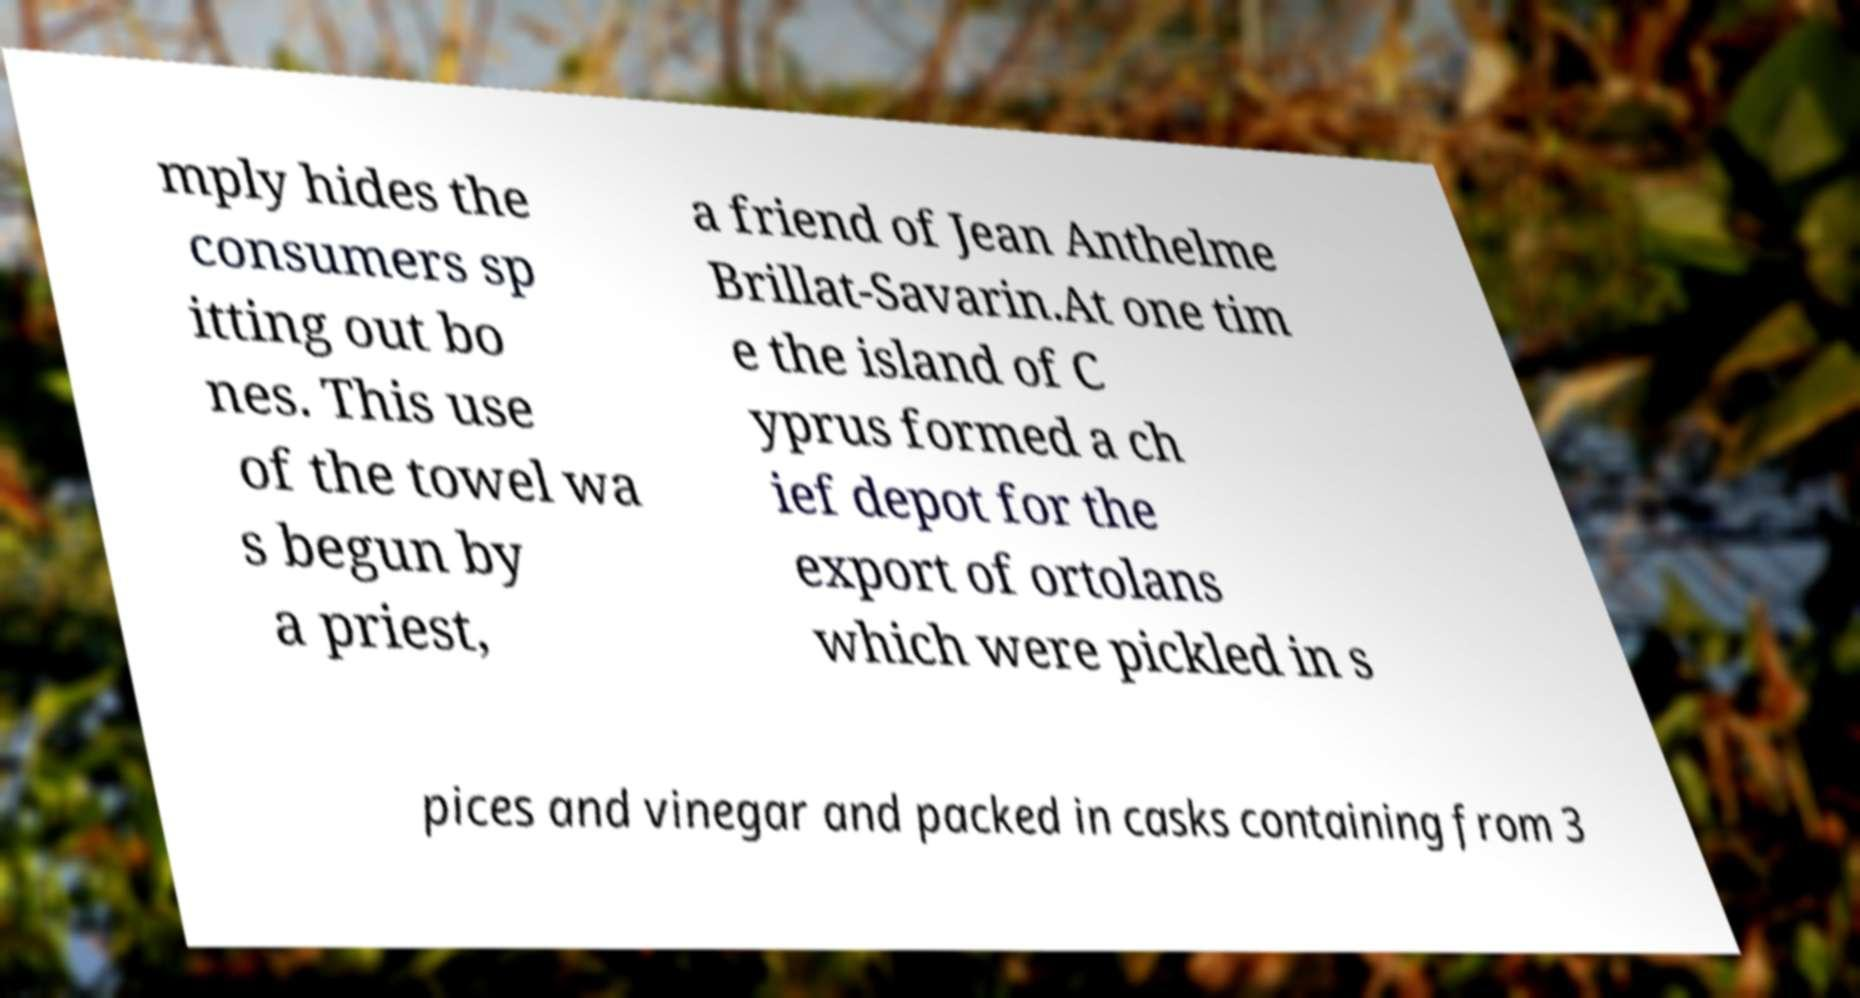Could you extract and type out the text from this image? mply hides the consumers sp itting out bo nes. This use of the towel wa s begun by a priest, a friend of Jean Anthelme Brillat-Savarin.At one tim e the island of C yprus formed a ch ief depot for the export of ortolans which were pickled in s pices and vinegar and packed in casks containing from 3 